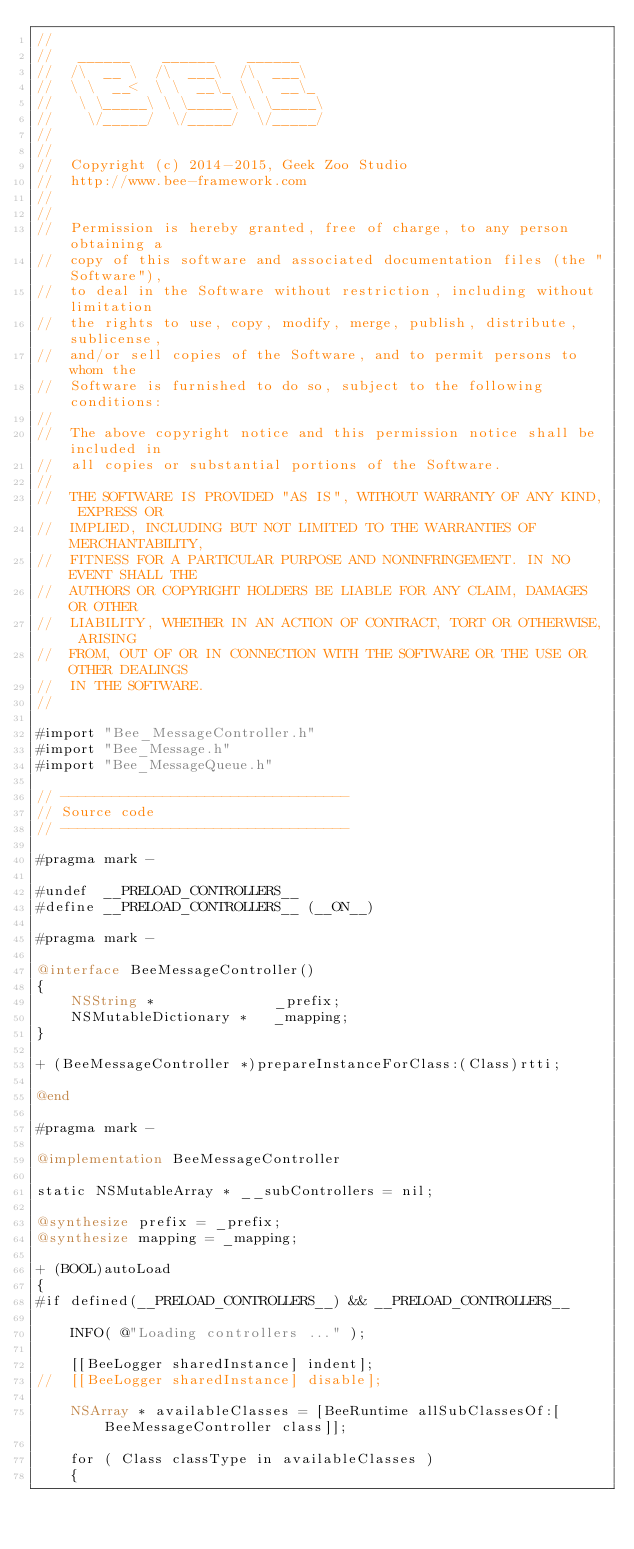Convert code to text. <code><loc_0><loc_0><loc_500><loc_500><_ObjectiveC_>//
//	 ______    ______    ______
//	/\  __ \  /\  ___\  /\  ___\
//	\ \  __<  \ \  __\_ \ \  __\_
//	 \ \_____\ \ \_____\ \ \_____\
//	  \/_____/  \/_____/  \/_____/
//
//
//	Copyright (c) 2014-2015, Geek Zoo Studio
//	http://www.bee-framework.com
//
//
//	Permission is hereby granted, free of charge, to any person obtaining a
//	copy of this software and associated documentation files (the "Software"),
//	to deal in the Software without restriction, including without limitation
//	the rights to use, copy, modify, merge, publish, distribute, sublicense,
//	and/or sell copies of the Software, and to permit persons to whom the
//	Software is furnished to do so, subject to the following conditions:
//
//	The above copyright notice and this permission notice shall be included in
//	all copies or substantial portions of the Software.
//
//	THE SOFTWARE IS PROVIDED "AS IS", WITHOUT WARRANTY OF ANY KIND, EXPRESS OR
//	IMPLIED, INCLUDING BUT NOT LIMITED TO THE WARRANTIES OF MERCHANTABILITY,
//	FITNESS FOR A PARTICULAR PURPOSE AND NONINFRINGEMENT. IN NO EVENT SHALL THE
//	AUTHORS OR COPYRIGHT HOLDERS BE LIABLE FOR ANY CLAIM, DAMAGES OR OTHER
//	LIABILITY, WHETHER IN AN ACTION OF CONTRACT, TORT OR OTHERWISE, ARISING
//	FROM, OUT OF OR IN CONNECTION WITH THE SOFTWARE OR THE USE OR OTHER DEALINGS
//	IN THE SOFTWARE.
//

#import "Bee_MessageController.h"
#import "Bee_Message.h"
#import "Bee_MessageQueue.h"

// ----------------------------------
// Source code
// ----------------------------------

#pragma mark -

#undef	__PRELOAD_CONTROLLERS__
#define __PRELOAD_CONTROLLERS__	(__ON__)

#pragma mark -

@interface BeeMessageController()
{
	NSString *				_prefix;
	NSMutableDictionary *	_mapping;
}

+ (BeeMessageController *)prepareInstanceForClass:(Class)rtti;

@end

#pragma mark -

@implementation BeeMessageController

static NSMutableArray * __subControllers = nil;

@synthesize prefix = _prefix;
@synthesize mapping = _mapping;

+ (BOOL)autoLoad
{
#if defined(__PRELOAD_CONTROLLERS__) && __PRELOAD_CONTROLLERS__
	
	INFO( @"Loading controllers ..." );
	
	[[BeeLogger sharedInstance] indent];
//	[[BeeLogger sharedInstance] disable];
	
	NSArray * availableClasses = [BeeRuntime allSubClassesOf:[BeeMessageController class]];
	
	for ( Class classType in availableClasses )
	{</code> 